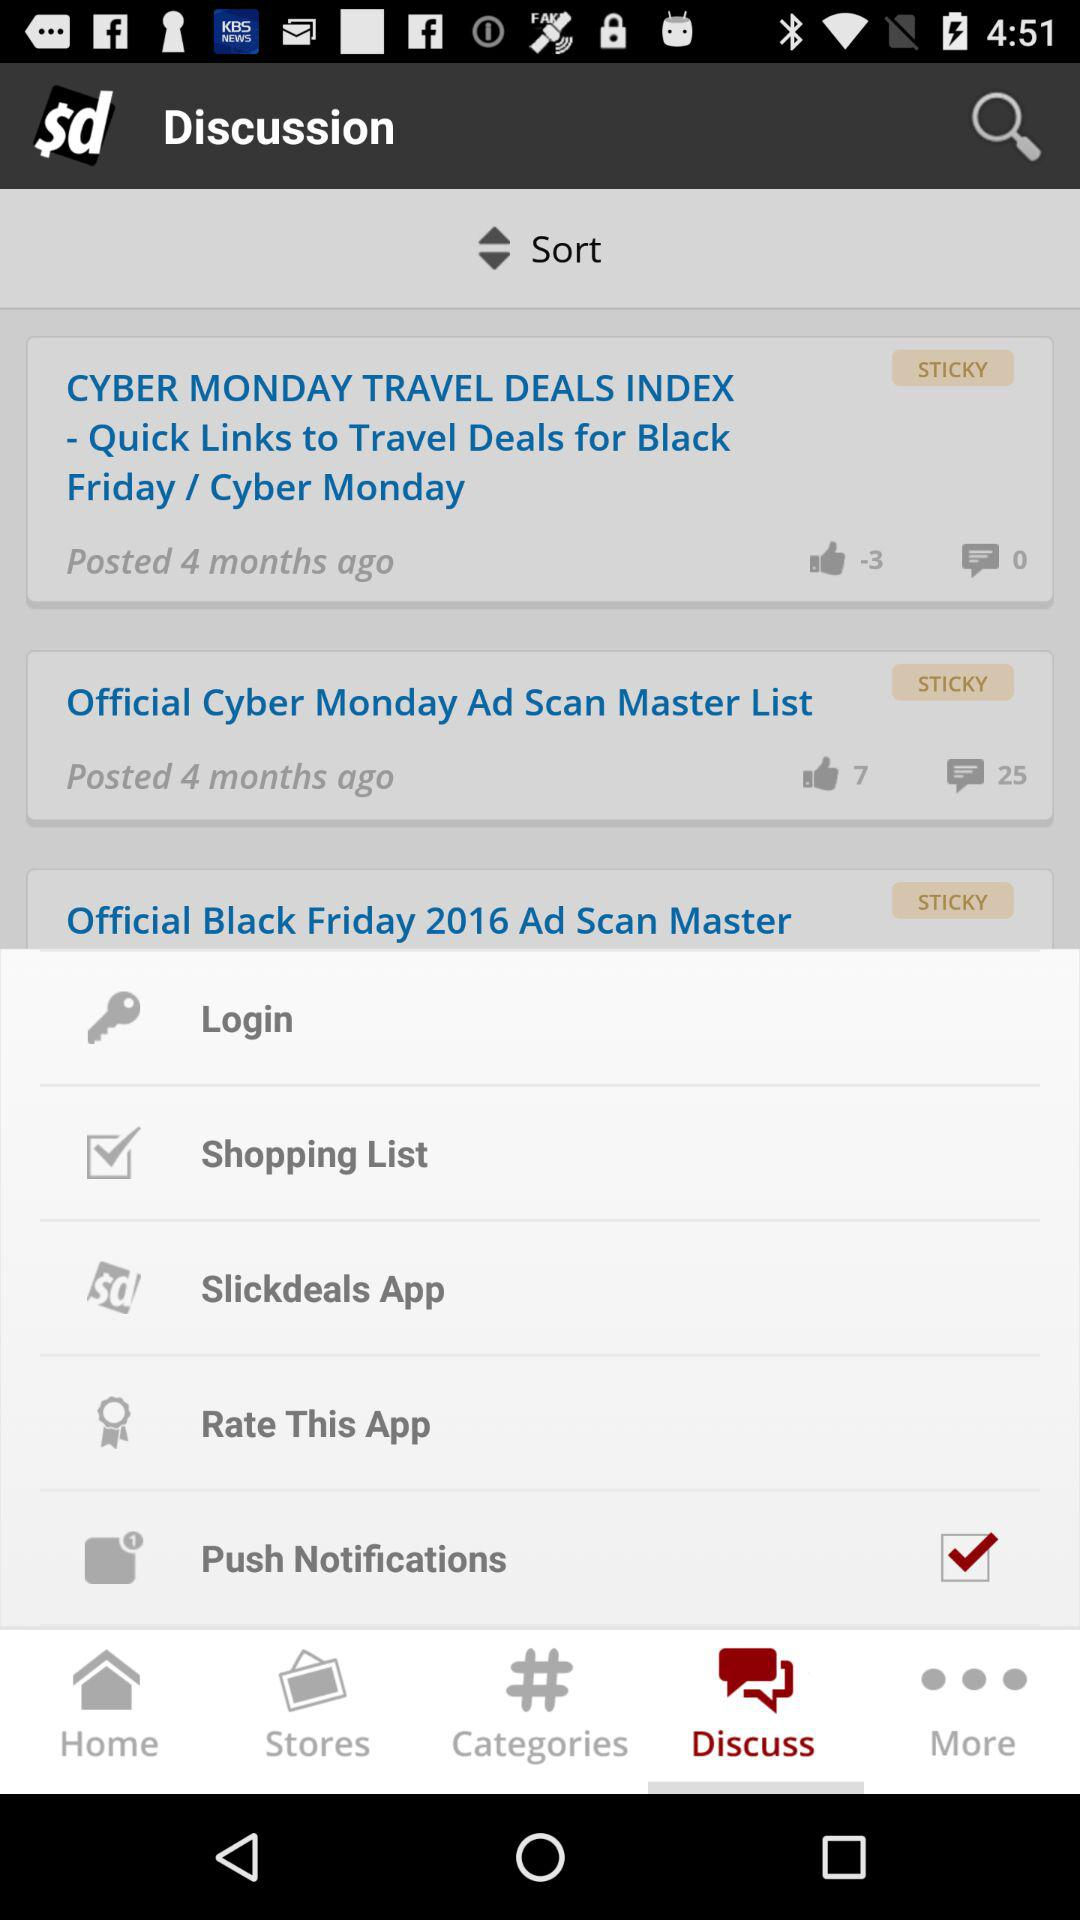Which tab is selected? The selected tab is "Discuss". 